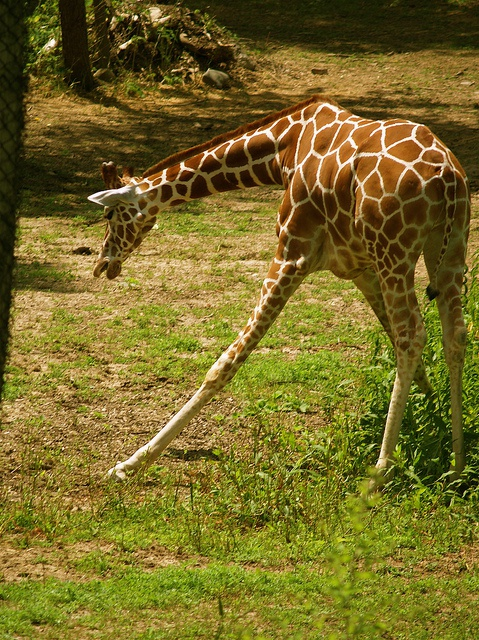Describe the objects in this image and their specific colors. I can see a giraffe in black, olive, and maroon tones in this image. 